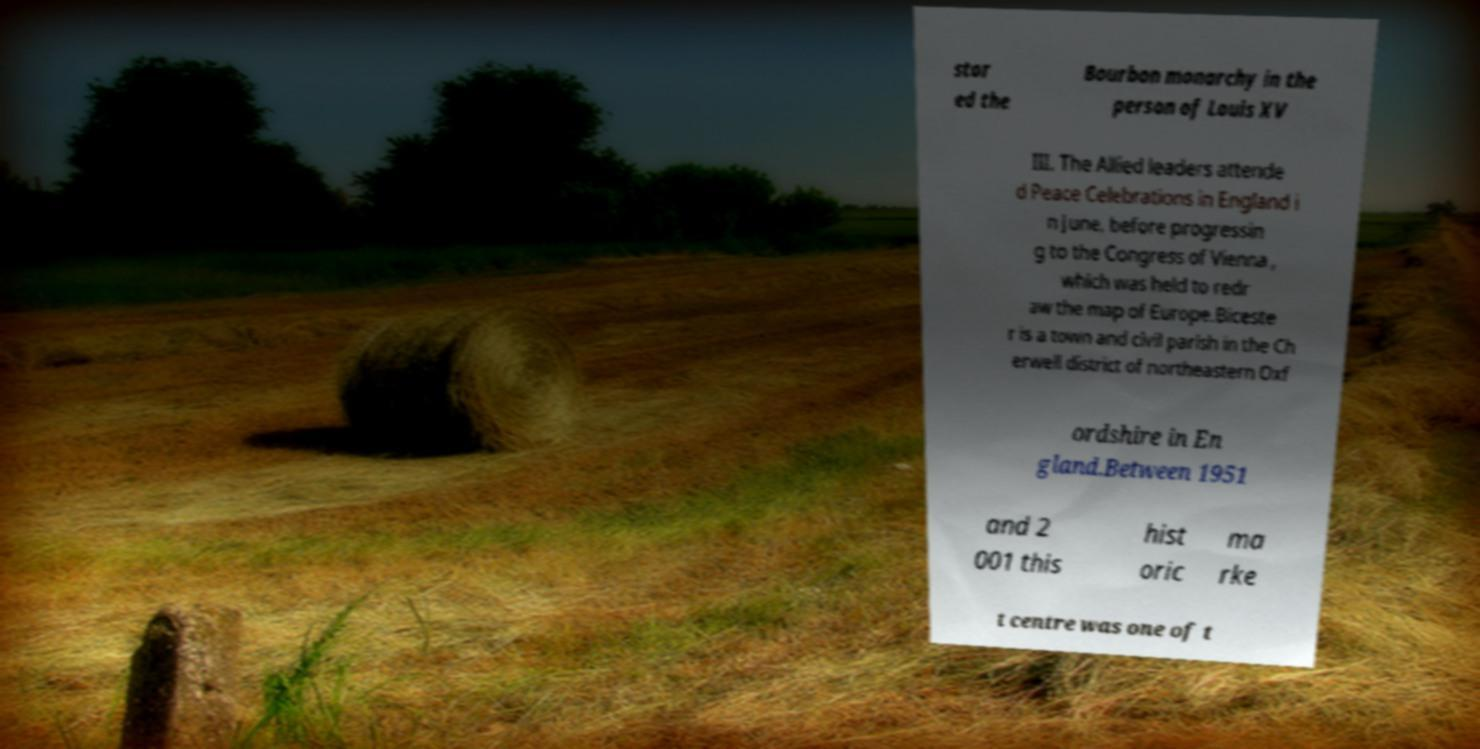For documentation purposes, I need the text within this image transcribed. Could you provide that? stor ed the Bourbon monarchy in the person of Louis XV III. The Allied leaders attende d Peace Celebrations in England i n June, before progressin g to the Congress of Vienna , which was held to redr aw the map of Europe.Biceste r is a town and civil parish in the Ch erwell district of northeastern Oxf ordshire in En gland.Between 1951 and 2 001 this hist oric ma rke t centre was one of t 